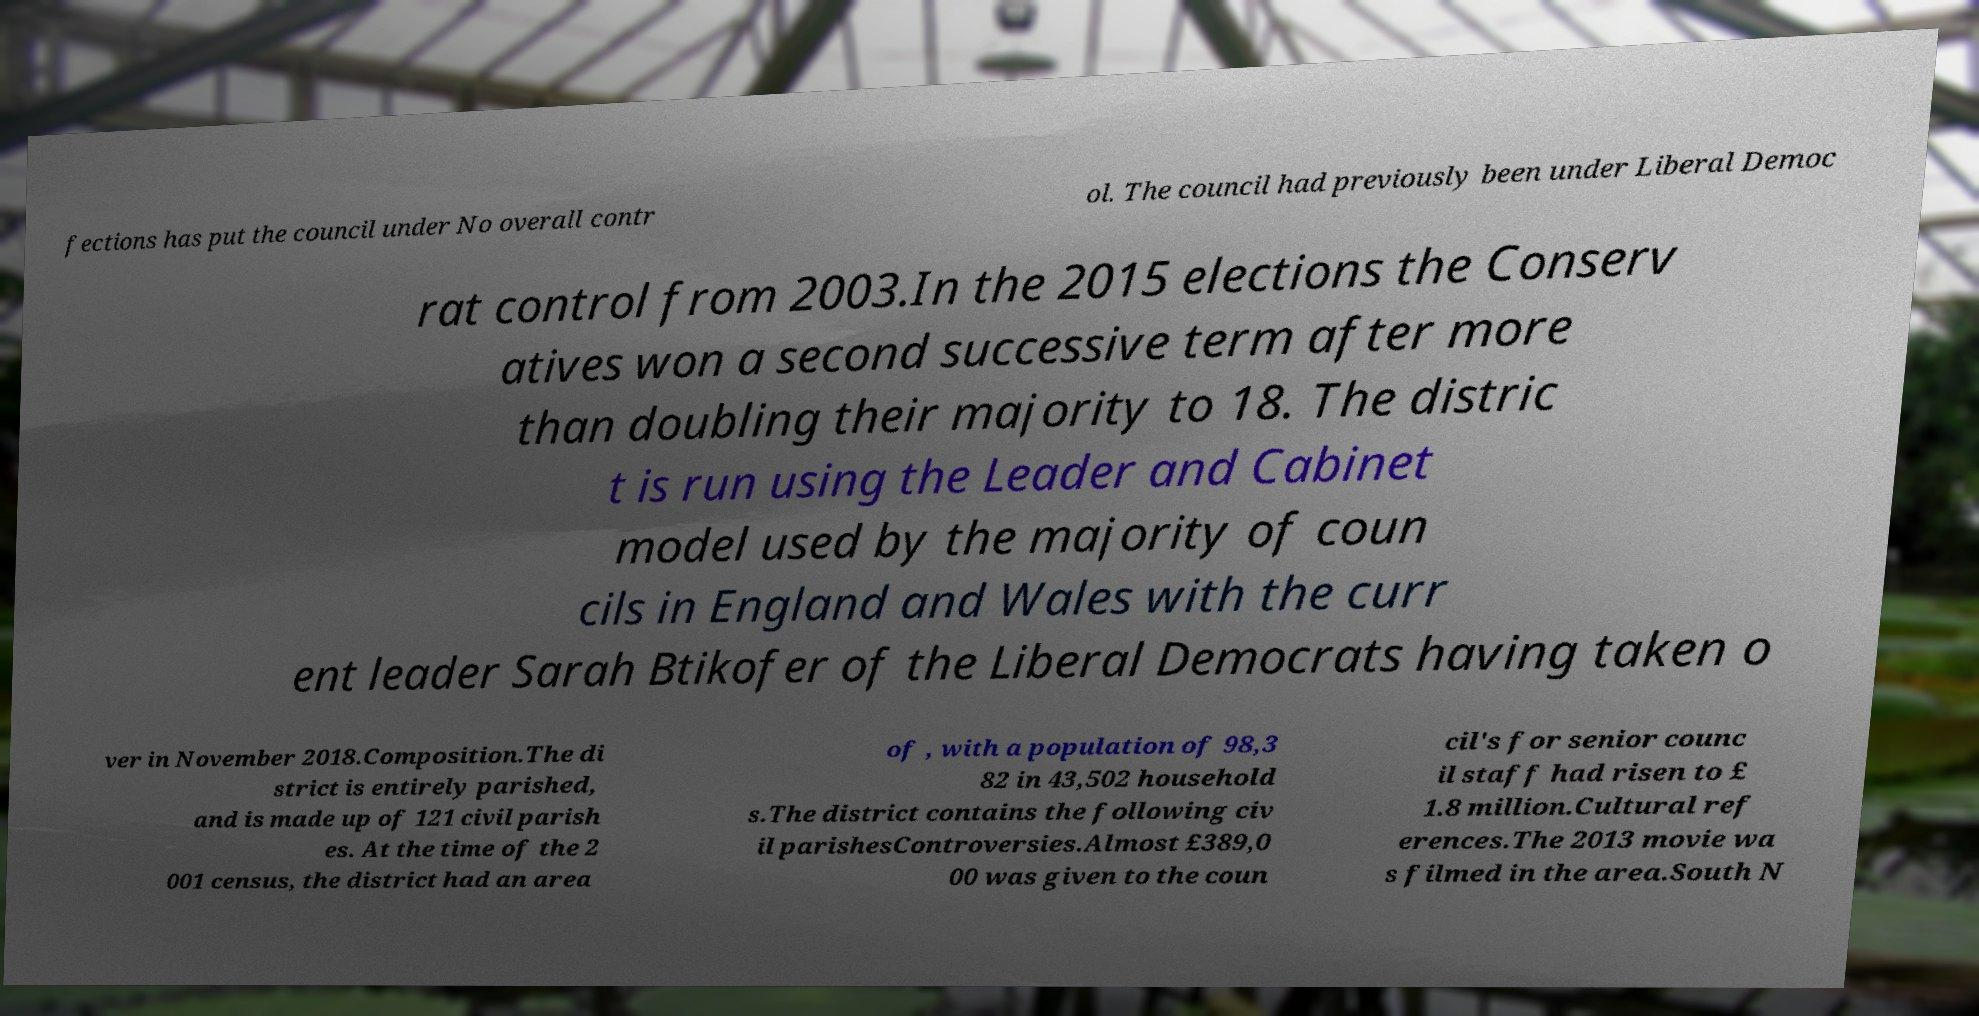What messages or text are displayed in this image? I need them in a readable, typed format. fections has put the council under No overall contr ol. The council had previously been under Liberal Democ rat control from 2003.In the 2015 elections the Conserv atives won a second successive term after more than doubling their majority to 18. The distric t is run using the Leader and Cabinet model used by the majority of coun cils in England and Wales with the curr ent leader Sarah Btikofer of the Liberal Democrats having taken o ver in November 2018.Composition.The di strict is entirely parished, and is made up of 121 civil parish es. At the time of the 2 001 census, the district had an area of , with a population of 98,3 82 in 43,502 household s.The district contains the following civ il parishesControversies.Almost £389,0 00 was given to the coun cil's for senior counc il staff had risen to £ 1.8 million.Cultural ref erences.The 2013 movie wa s filmed in the area.South N 